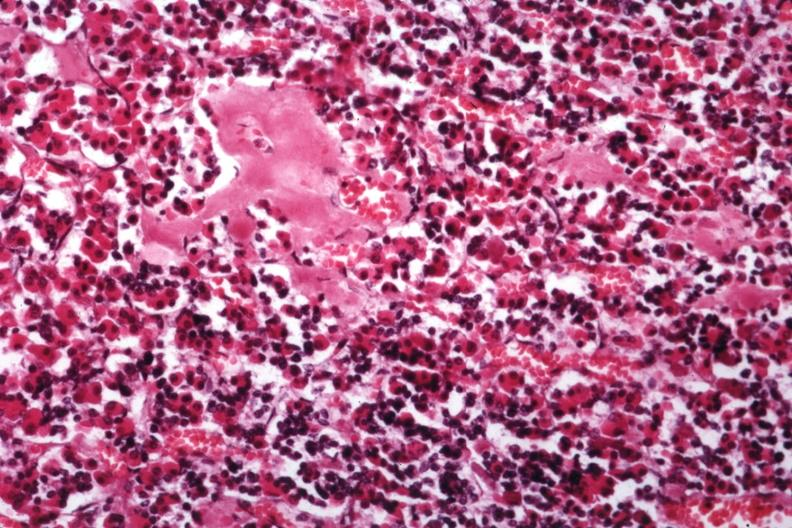s amyloidosis present?
Answer the question using a single word or phrase. Yes 